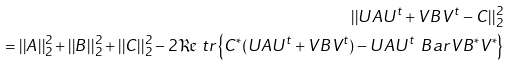Convert formula to latex. <formula><loc_0><loc_0><loc_500><loc_500>| | U A U ^ { t } + V B V ^ { t } - C | | _ { 2 } ^ { 2 } \\ = | | A | | _ { 2 } ^ { 2 } + | | B | | _ { 2 } ^ { 2 } + | | C | | _ { 2 } ^ { 2 } - 2 \Re \ t r \left \{ C ^ { * } ( U A U ^ { t } + V B V ^ { t } ) - U A U ^ { t } \, \ B a r V B ^ { * } V ^ { * } \right \}</formula> 